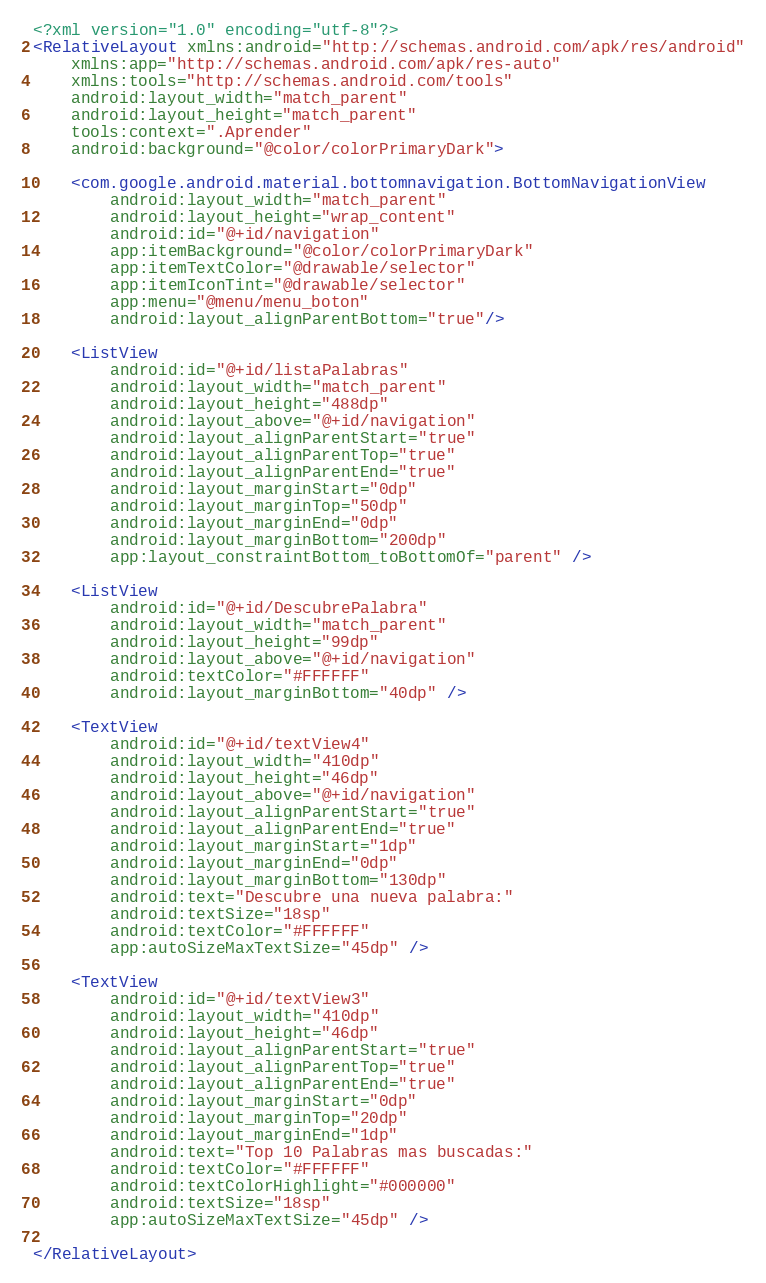<code> <loc_0><loc_0><loc_500><loc_500><_XML_><?xml version="1.0" encoding="utf-8"?>
<RelativeLayout xmlns:android="http://schemas.android.com/apk/res/android"
    xmlns:app="http://schemas.android.com/apk/res-auto"
    xmlns:tools="http://schemas.android.com/tools"
    android:layout_width="match_parent"
    android:layout_height="match_parent"
    tools:context=".Aprender"
    android:background="@color/colorPrimaryDark">

    <com.google.android.material.bottomnavigation.BottomNavigationView
        android:layout_width="match_parent"
        android:layout_height="wrap_content"
        android:id="@+id/navigation"
        app:itemBackground="@color/colorPrimaryDark"
        app:itemTextColor="@drawable/selector"
        app:itemIconTint="@drawable/selector"
        app:menu="@menu/menu_boton"
        android:layout_alignParentBottom="true"/>

    <ListView
        android:id="@+id/listaPalabras"
        android:layout_width="match_parent"
        android:layout_height="488dp"
        android:layout_above="@+id/navigation"
        android:layout_alignParentStart="true"
        android:layout_alignParentTop="true"
        android:layout_alignParentEnd="true"
        android:layout_marginStart="0dp"
        android:layout_marginTop="50dp"
        android:layout_marginEnd="0dp"
        android:layout_marginBottom="200dp"
        app:layout_constraintBottom_toBottomOf="parent" />

    <ListView
        android:id="@+id/DescubrePalabra"
        android:layout_width="match_parent"
        android:layout_height="99dp"
        android:layout_above="@+id/navigation"
        android:textColor="#FFFFFF"
        android:layout_marginBottom="40dp" />

    <TextView
        android:id="@+id/textView4"
        android:layout_width="410dp"
        android:layout_height="46dp"
        android:layout_above="@+id/navigation"
        android:layout_alignParentStart="true"
        android:layout_alignParentEnd="true"
        android:layout_marginStart="1dp"
        android:layout_marginEnd="0dp"
        android:layout_marginBottom="130dp"
        android:text="Descubre una nueva palabra:"
        android:textSize="18sp"
        android:textColor="#FFFFFF"
        app:autoSizeMaxTextSize="45dp" />

    <TextView
        android:id="@+id/textView3"
        android:layout_width="410dp"
        android:layout_height="46dp"
        android:layout_alignParentStart="true"
        android:layout_alignParentTop="true"
        android:layout_alignParentEnd="true"
        android:layout_marginStart="0dp"
        android:layout_marginTop="20dp"
        android:layout_marginEnd="1dp"
        android:text="Top 10 Palabras mas buscadas:"
        android:textColor="#FFFFFF"
        android:textColorHighlight="#000000"
        android:textSize="18sp"
        app:autoSizeMaxTextSize="45dp" />

</RelativeLayout>
</code> 